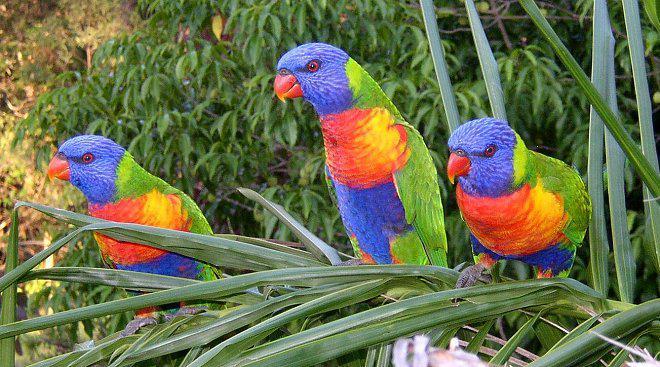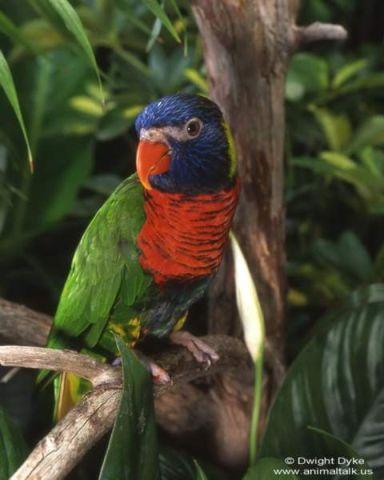The first image is the image on the left, the second image is the image on the right. For the images displayed, is the sentence "There are no more than four birds" factually correct? Answer yes or no. Yes. The first image is the image on the left, the second image is the image on the right. Analyze the images presented: Is the assertion "Right image contains exactly one parrot." valid? Answer yes or no. Yes. 